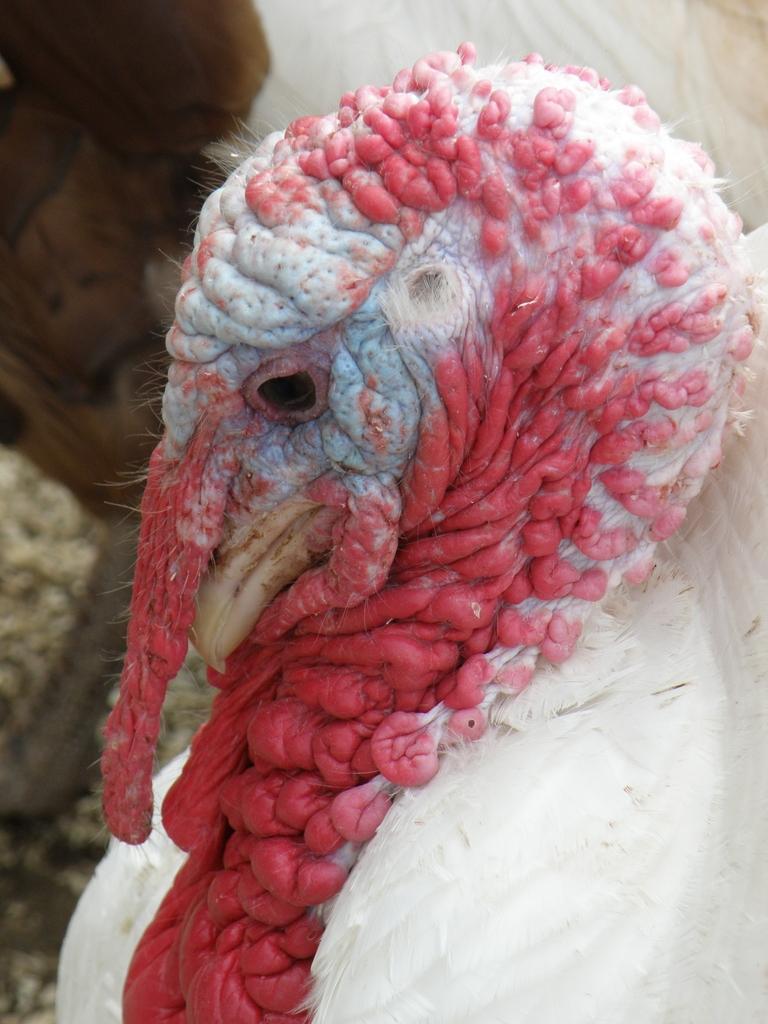Describe this image in one or two sentences. In this picture we can see a white color domestic turkey here. 